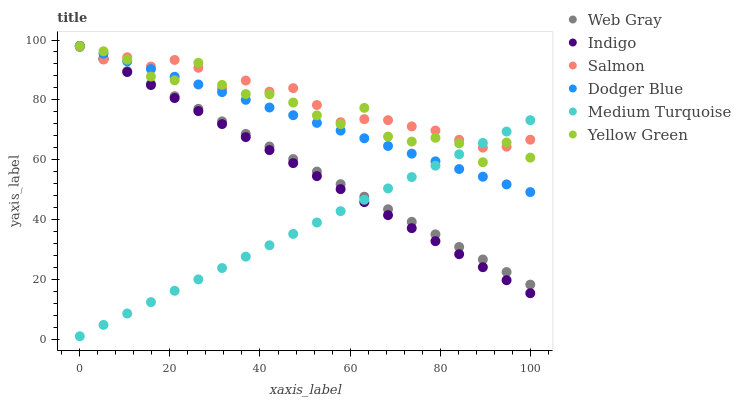Does Medium Turquoise have the minimum area under the curve?
Answer yes or no. Yes. Does Salmon have the maximum area under the curve?
Answer yes or no. Yes. Does Indigo have the minimum area under the curve?
Answer yes or no. No. Does Indigo have the maximum area under the curve?
Answer yes or no. No. Is Medium Turquoise the smoothest?
Answer yes or no. Yes. Is Yellow Green the roughest?
Answer yes or no. Yes. Is Indigo the smoothest?
Answer yes or no. No. Is Indigo the roughest?
Answer yes or no. No. Does Medium Turquoise have the lowest value?
Answer yes or no. Yes. Does Indigo have the lowest value?
Answer yes or no. No. Does Dodger Blue have the highest value?
Answer yes or no. Yes. Does Salmon have the highest value?
Answer yes or no. No. Does Dodger Blue intersect Salmon?
Answer yes or no. Yes. Is Dodger Blue less than Salmon?
Answer yes or no. No. Is Dodger Blue greater than Salmon?
Answer yes or no. No. 